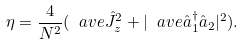Convert formula to latex. <formula><loc_0><loc_0><loc_500><loc_500>\eta = \frac { 4 } { N ^ { 2 } } ( \ a v e { \hat { J } _ { z } } ^ { 2 } + | \ a v e { \hat { a } ^ { \dagger } _ { 1 } \hat { a } _ { 2 } } | ^ { 2 } ) .</formula> 